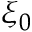<formula> <loc_0><loc_0><loc_500><loc_500>\xi _ { 0 }</formula> 